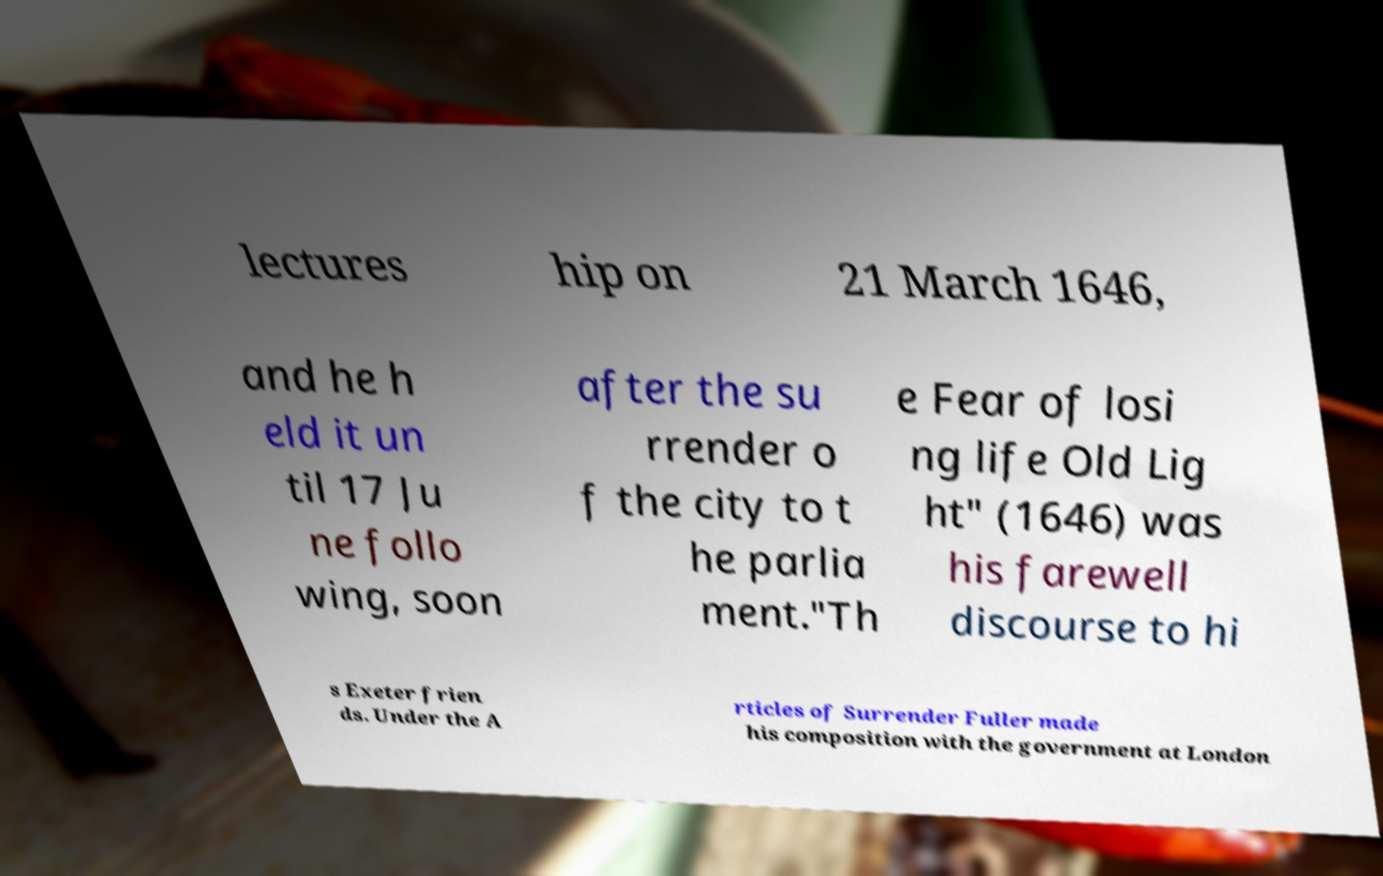Please read and relay the text visible in this image. What does it say? lectures hip on 21 March 1646, and he h eld it un til 17 Ju ne follo wing, soon after the su rrender o f the city to t he parlia ment."Th e Fear of losi ng life Old Lig ht" (1646) was his farewell discourse to hi s Exeter frien ds. Under the A rticles of Surrender Fuller made his composition with the government at London 